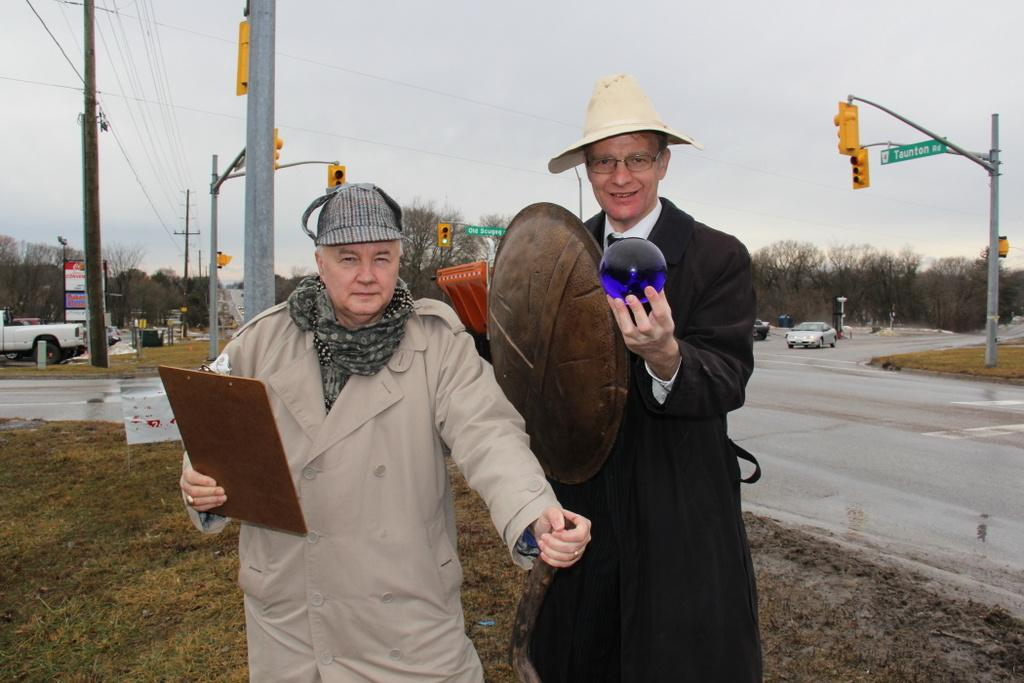How many men are in the image? There are two men in the image. What are the men wearing? One man is wearing a black suit, and the other is wearing a grey suit. What are the men doing in the image? The two men are standing beside each other. What can be seen in the background of the image? There are vehicles visible on a road, and there are traffic lights on either side of the road. What type of holiday is being celebrated in the image? There is no indication of a holiday being celebrated in the image. Can you see an owl perched on the traffic light in the image? No, there is no owl present in the image. 